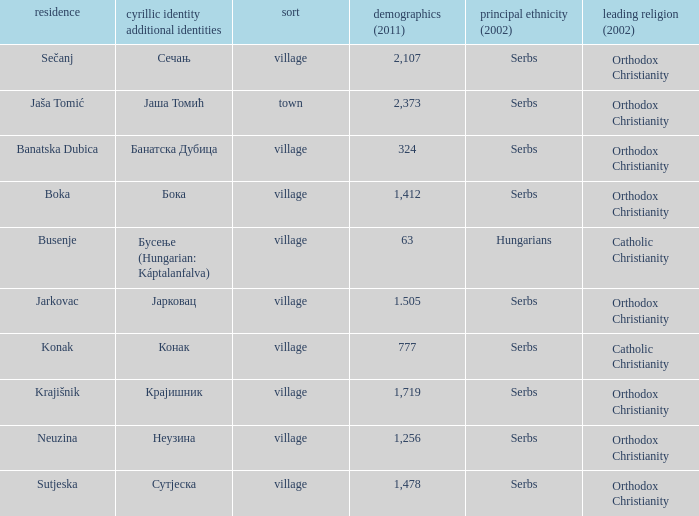The population is 2,107's dominant religion is? Orthodox Christianity. 